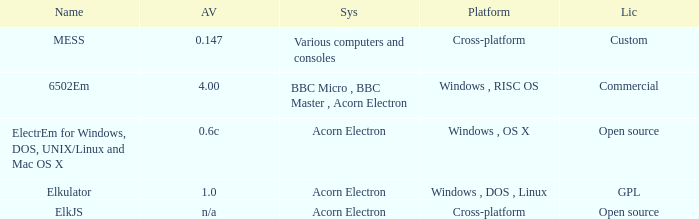What is the title of the platform utilized for multiple computers and gaming consoles? Cross-platform. 